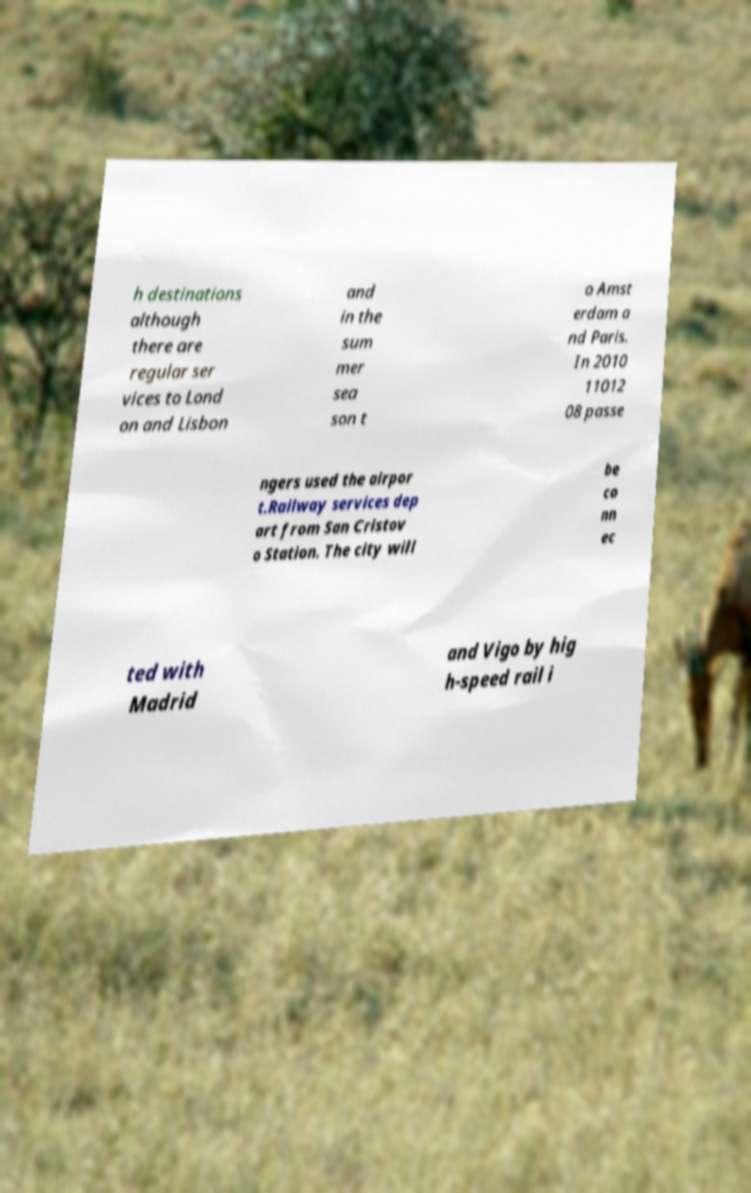Can you read and provide the text displayed in the image?This photo seems to have some interesting text. Can you extract and type it out for me? h destinations although there are regular ser vices to Lond on and Lisbon and in the sum mer sea son t o Amst erdam a nd Paris. In 2010 11012 08 passe ngers used the airpor t.Railway services dep art from San Cristov o Station. The city will be co nn ec ted with Madrid and Vigo by hig h-speed rail i 